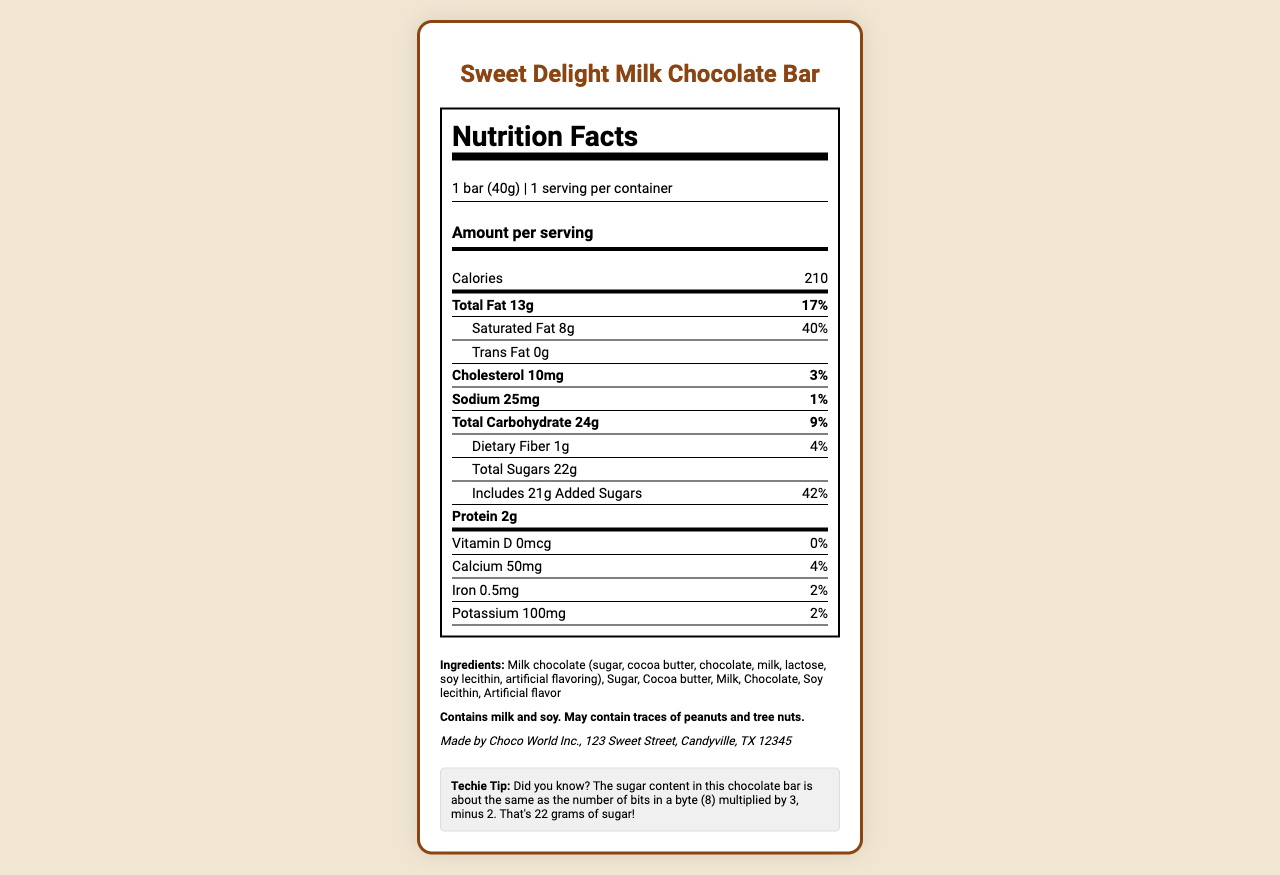what is the serving size of the Sweet Delight Milk Chocolate Bar? The serving size is indicated as "1 bar (40g)" under the serving information.
Answer: 1 bar (40g) how many calories are in one serving? The number of calories per serving is listed as 210.
Answer: 210 what is the percentage of daily value for saturated fat? The label shows that the saturated fat content is 8g, which corresponds to 40% of the daily value.
Answer: 40% how much protein does the chocolate bar contain? The protein content is listed as 2g.
Answer: 2g name two main ingredients of the chocolate bar? The main ingredients listed first are "Milk chocolate" and "Sugar".
Answer: Milk chocolate (sugar, cocoa butter, chocolate, milk, lactose, soy lecithin, artificial flavoring), Sugar how much sodium does one serving contain?
   A. 10mg
   B. 25mg
   C. 50mg
   D. 100mg The sodium content per serving is listed as 25mg, which matches option B.
Answer: B. 25mg what is the percentage of daily value for total carbohydrate in the chocolate bar?
   I. 8%
   II. 9%
   III. 17%
   IV. 20% The total carbohydrate daily value percentage is listed as 9%, corresponding to option II.
Answer: II. 9% does the chocolate bar contain any trans fat? The label indicates "Trans Fat 0g," meaning there is no trans fat in the chocolate bar.
Answer: No summarize the main nutritional components of this chocolate bar, including the serving size and key nutrients. This summary highlights the main nutritional components and their daily values based on the information provided in the label.
Answer: The Sweet Delight Milk Chocolate Bar has a serving size of 1 bar (40g) and contains 210 calories. Key nutrients include 13g total fat (17% DV), 8g saturated fat (40% DV), 25mg sodium (1% DV), 24g total carbohydrate (9% DV), 1g dietary fiber (4% DV), 22g total sugars, including 21g added sugars (42% DV), and 2g protein. It also provides minor amounts of calcium, iron, and potassium. what is the percentage of daily value for dietary fiber in the chocolate bar? The dietary fiber content is 1g, which corresponds to 4% of the daily value.
Answer: 4% how many grams of added sugars are in one serving? The label specifies that the chocolate bar includes 21g of added sugars.
Answer: 21g which company manufactures the Sweet Delight Milk Chocolate Bar? The manufacturer information specifies that it is made by Choco World Inc.
Answer: Choco World Inc. is there any vitamin D in this chocolate bar? The label shows "Vitamin D 0mcg," indicating there is no vitamin D in the chocolate bar.
Answer: No what other allergens may be present in the chocolate bar apart from milk and soy? The allergen information mentions that the chocolate bar may contain traces of peanuts and tree nuts.
Answer: Traces of peanuts and tree nuts explain the techie tip provided in the document about sugar content. The techie tip gives an interesting comparison by showing how 22 grams of sugar equates to the calculation involving bits and bytes.
Answer: The techie tip explains that the sugar content (22 grams) can be related to the number of bits in a byte (8) multiplied by 3, minus 2. what is the exact street address of the manufacturer? The manufacturer information provides the address as "123 Sweet Street, Candyville, TX 12345".
Answer: 123 Sweet Street, Candyville, TX 12345 what is the cost of the chocolate bar? The document does not provide any information regarding the price or cost of the chocolate bar.
Answer: Cannot be determined 